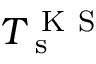<formula> <loc_0><loc_0><loc_500><loc_500>T _ { s } ^ { K S }</formula> 